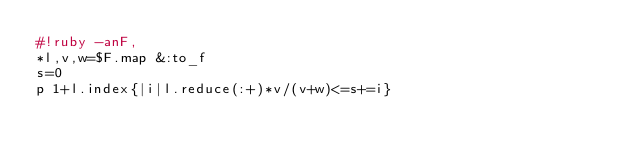Convert code to text. <code><loc_0><loc_0><loc_500><loc_500><_Ruby_>#!ruby -anF,
*l,v,w=$F.map &:to_f
s=0
p 1+l.index{|i|l.reduce(:+)*v/(v+w)<=s+=i}</code> 